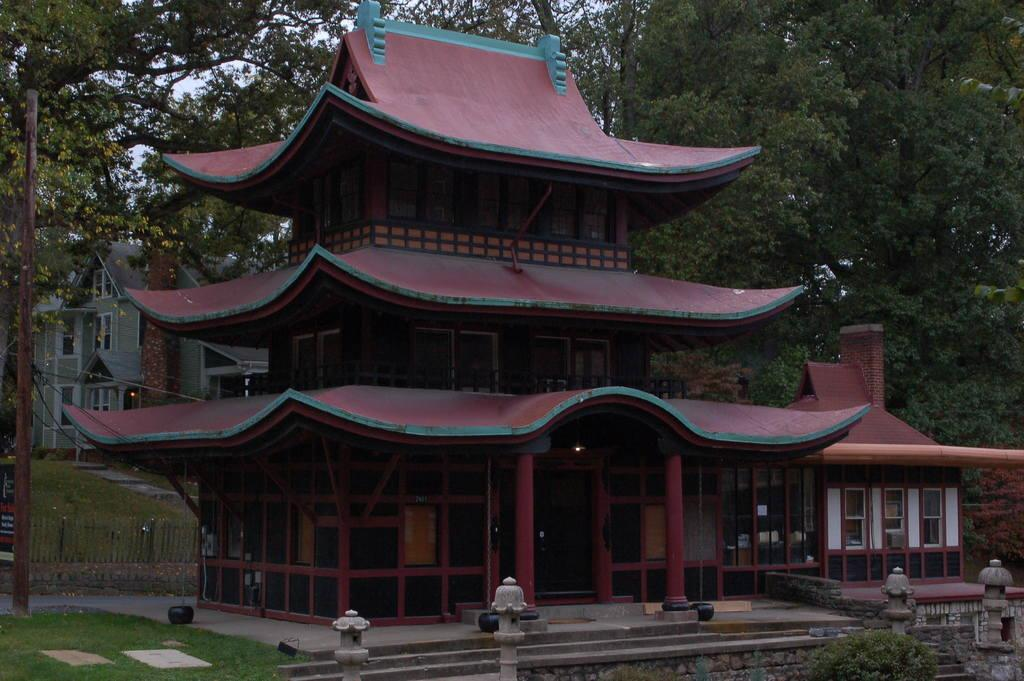What type of structure is visible in the image? There is a house in the image. What color is the house? The house is red in color. What can be seen on the right side of the image? There are green trees on the right side of the image. What verse is being recited by the kittens in the image? There are no kittens or verses present in the image. 